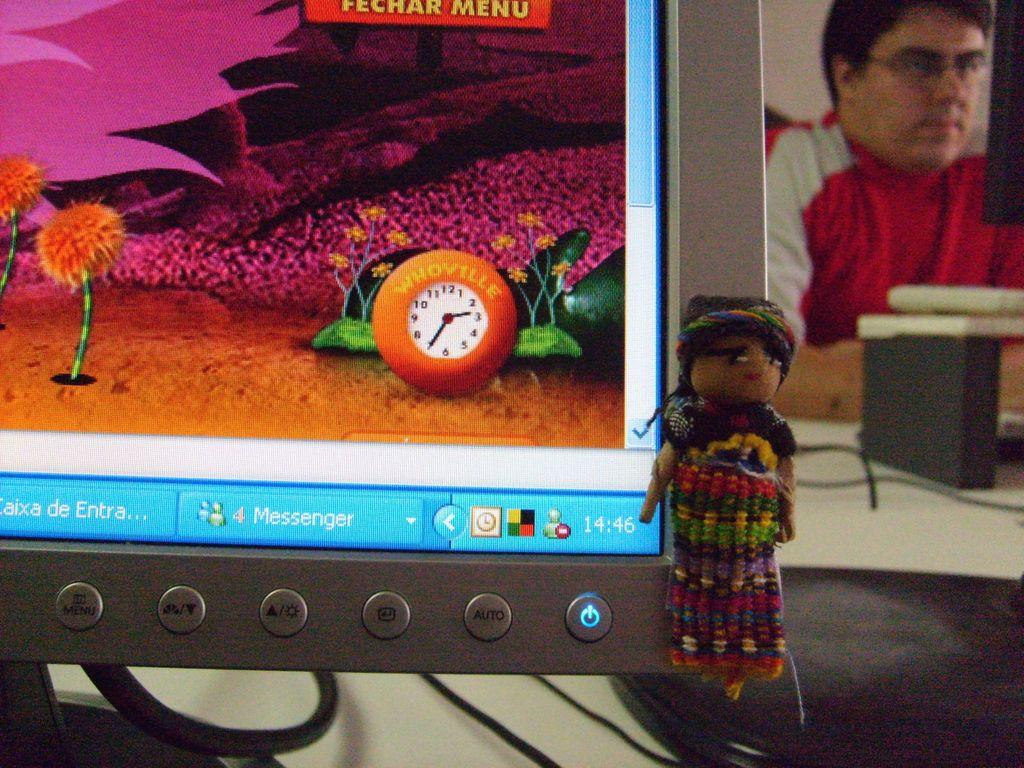What piece of furniture is present in the image? There is a table in the image. What is placed on the table? There is a computer on the table. What is the man in the image doing? The man is sitting on a chair in the image. What type of drain is visible in the image? There is no drain present in the image. Are there any pests visible in the image? There are no pests visible in the image. 